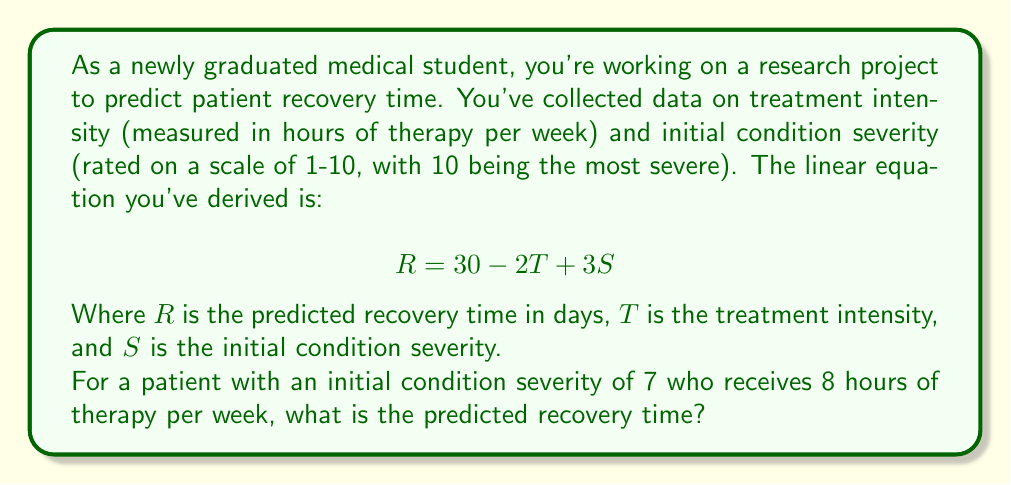Teach me how to tackle this problem. Let's approach this step-by-step:

1) We have the linear equation: $$R = 30 - 2T + 3S$$

2) We're given that:
   - Initial condition severity (S) = 7
   - Treatment intensity (T) = 8 hours per week

3) Let's substitute these values into our equation:
   $$R = 30 - 2(8) + 3(7)$$

4) First, let's calculate $-2T$:
   $$R = 30 - 16 + 3(7)$$

5) Now, let's calculate $3S$:
   $$R = 30 - 16 + 21$$

6) Finally, let's add all the terms:
   $$R = 30 - 16 + 21 = 35$$

Therefore, the predicted recovery time for this patient is 35 days.
Answer: 35 days 